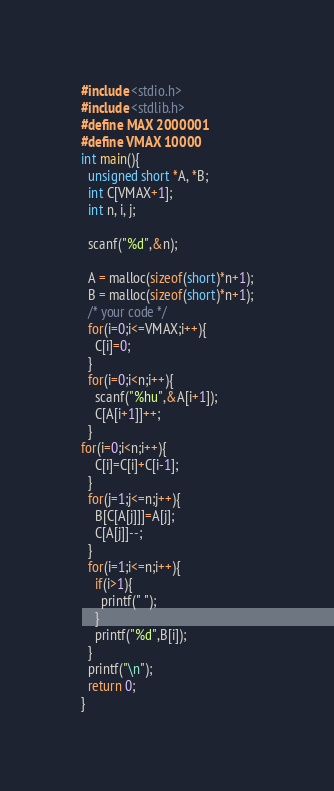Convert code to text. <code><loc_0><loc_0><loc_500><loc_500><_C_>#include <stdio.h>
#include <stdlib.h>
#define MAX 2000001
#define VMAX 10000
int main(){
  unsigned short *A, *B;
  int C[VMAX+1];
  int n, i, j;

  scanf("%d",&n);

  A = malloc(sizeof(short)*n+1);
  B = malloc(sizeof(short)*n+1);
  /* your code */
  for(i=0;i<=VMAX;i++){
    C[i]=0;
  }
  for(i=0;i<n;i++){
    scanf("%hu",&A[i+1]);
    C[A[i+1]]++;
  }
for(i=0;i<n;i++){
    C[i]=C[i]+C[i-1];
  }
  for(j=1;j<=n;j++){
    B[C[A[j]]]=A[j];
    C[A[j]]--;
  }
  for(i=1;i<=n;i++){
    if(i>1){
      printf(" ");
    }
    printf("%d",B[i]);
  }
  printf("\n");
  return 0;
}
</code> 